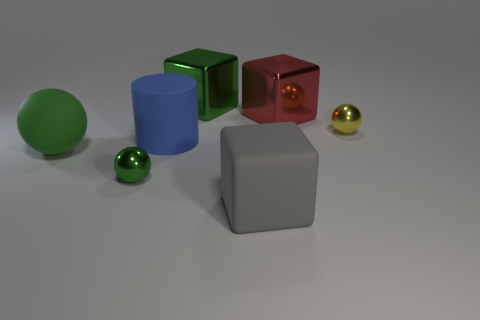Are there more small green things behind the big blue matte cylinder than small metal balls that are on the right side of the yellow thing?
Provide a succinct answer. No. What color is the rubber cylinder that is the same size as the gray block?
Give a very brief answer. Blue. Is there a big cylinder that has the same color as the large matte block?
Make the answer very short. No. There is a small thing to the right of the red shiny object; is it the same color as the tiny shiny object left of the yellow metal object?
Ensure brevity in your answer.  No. What is the material of the cube that is behind the large red metallic block?
Offer a terse response. Metal. What is the color of the ball that is the same material as the large gray cube?
Offer a very short reply. Green. How many red cubes are the same size as the green metal cube?
Make the answer very short. 1. Does the green shiny thing in front of the green metallic cube have the same size as the red block?
Your answer should be compact. No. What is the shape of the shiny object that is to the left of the big matte block and behind the large green matte ball?
Provide a short and direct response. Cube. There is a green matte object; are there any rubber objects on the left side of it?
Provide a succinct answer. No. 